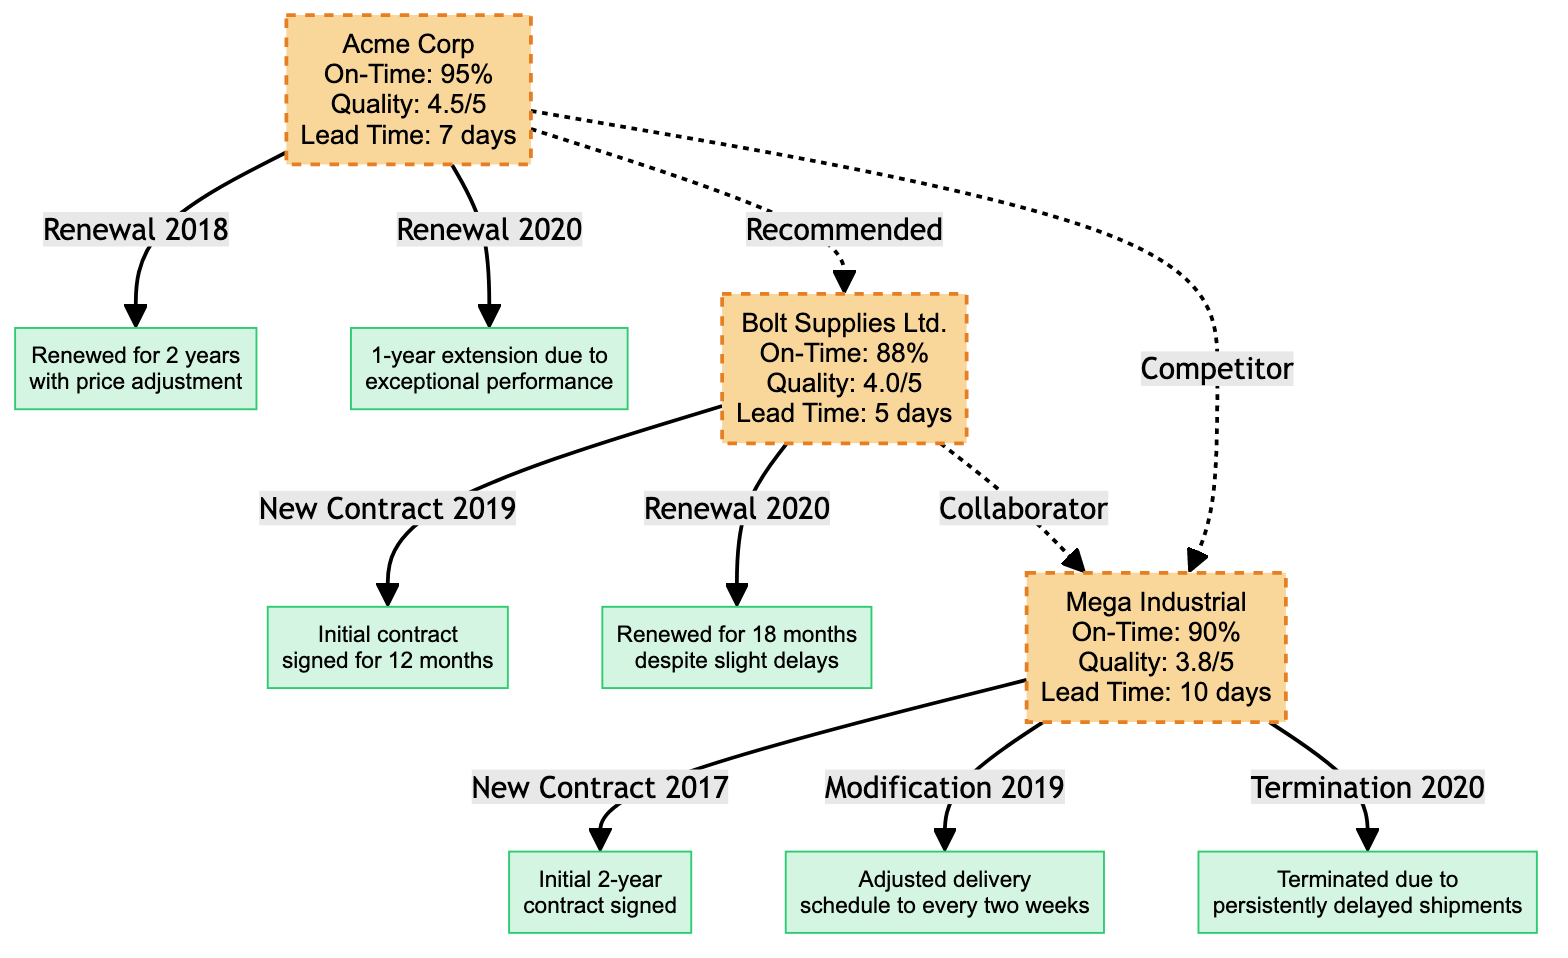What is the on-time delivery percentage of Acme Corp? The on-time delivery percentage for Acme Corp is displayed directly in the node labeled "Acme Corp," which shows "On-Time: 95%."
Answer: 95% What type of contract change did Bolt Supplies Ltd. experience in 2019? The diagram specifies that Bolt Supplies Ltd. had a "New Contract" in 2019 with the description "Initial contract signed for 12 months."
Answer: New Contract Name a vendor that Acme Corp recommends. The connection labeled "Recommended" from Acme Corp indicates that Bolt Supplies Ltd. is the vendor that was recommended.
Answer: Bolt Supplies Ltd What was the quality score of Mega Industrial? The quality score is presented in the Mega Industrial node as "Quality: 3.8/5," indicating its performance score.
Answer: 3.8/5 How many total contract changes occurred for Mega Industrial? By counting the contract changes listed under Mega Industrial, there are three: a New Contract, a Modification, and a Termination.
Answer: 3 What type of relationship exists between Bolt Supplies Ltd. and Mega Industrial? The diagram states that the relation is labeled "Collaborator," indicating a working partnership between the two vendors.
Answer: Collaborator Which vendor had a contract terminated in 2020? The diagram clearly shows that Mega Industrial had a contract termination in 2020 due to persistently delayed shipments.
Answer: Mega Industrial What was the average lead time for Bolt Supplies Ltd.? According to the performance metrics in the Bolt Supplies Ltd. node, the average lead time is stated as "5 days."
Answer: 5 days What was the type of relationship between Acme Corp and Mega Industrial? The relationship indicated as "Competitor" describes the nature between Acme Corp and Mega Industrial, suggesting they compete for contracts.
Answer: Competitor 